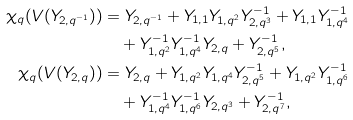Convert formula to latex. <formula><loc_0><loc_0><loc_500><loc_500>\chi _ { q } ( V ( Y _ { 2 , q ^ { - 1 } } ) ) & = Y _ { 2 , q ^ { - 1 } } + Y _ { 1 , 1 } Y _ { 1 , q ^ { 2 } } Y ^ { - 1 } _ { 2 , q ^ { 3 } } + Y _ { 1 , 1 } Y ^ { - 1 } _ { 1 , q ^ { 4 } } \\ & \quad + Y ^ { - 1 } _ { 1 , q ^ { 2 } } Y ^ { - 1 } _ { 1 , q ^ { 4 } } Y _ { 2 , q } + Y ^ { - 1 } _ { 2 , q ^ { 5 } } , \\ \chi _ { q } ( V ( Y _ { 2 , q } ) ) & = Y _ { 2 , q } + Y _ { 1 , q ^ { 2 } } Y _ { 1 , q ^ { 4 } } Y ^ { - 1 } _ { 2 , q ^ { 5 } } + Y _ { 1 , q ^ { 2 } } Y ^ { - 1 } _ { 1 , q ^ { 6 } } \\ & \quad + Y ^ { - 1 } _ { 1 , q ^ { 4 } } Y ^ { - 1 } _ { 1 , q ^ { 6 } } Y _ { 2 , q ^ { 3 } } + Y ^ { - 1 } _ { 2 , q ^ { 7 } } ,</formula> 